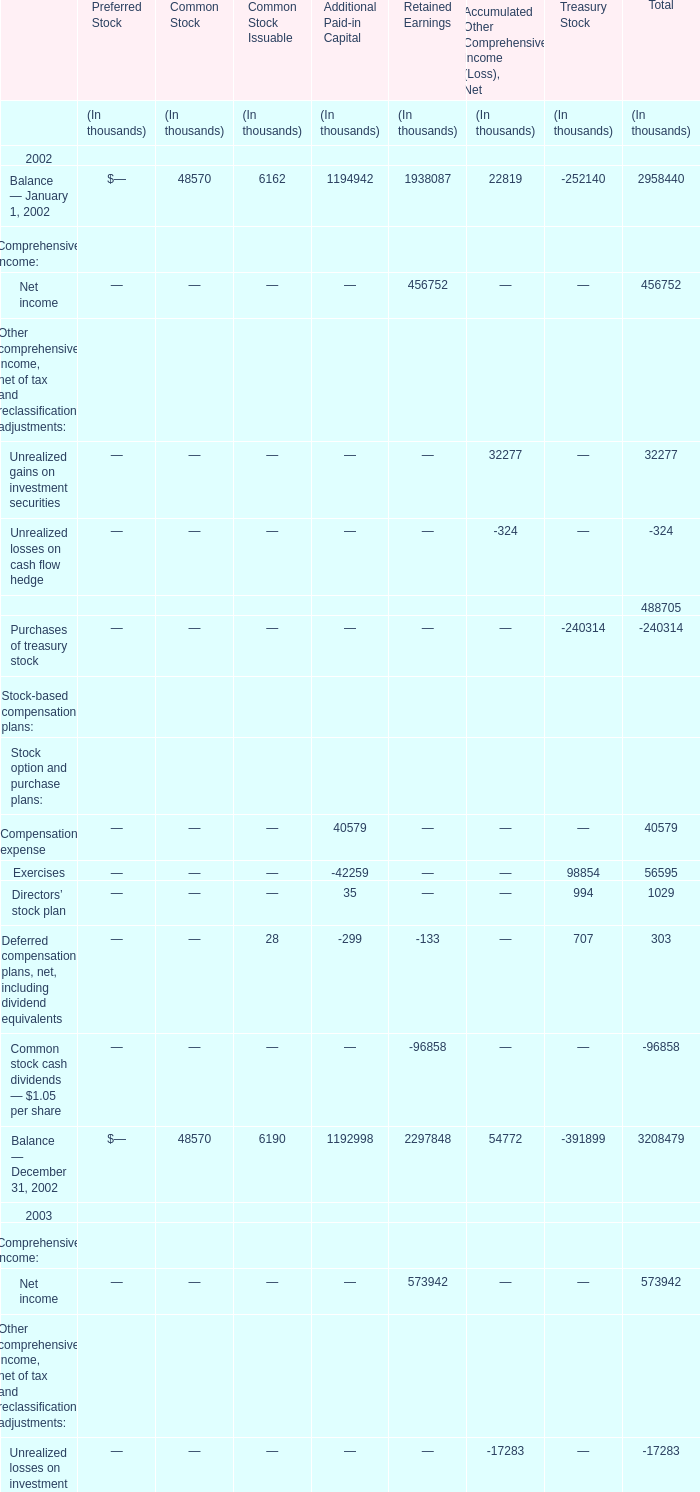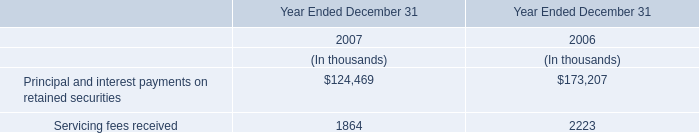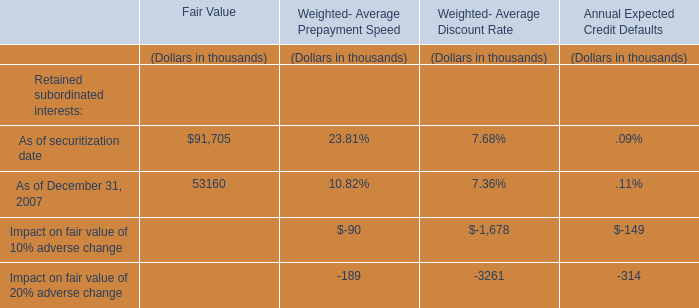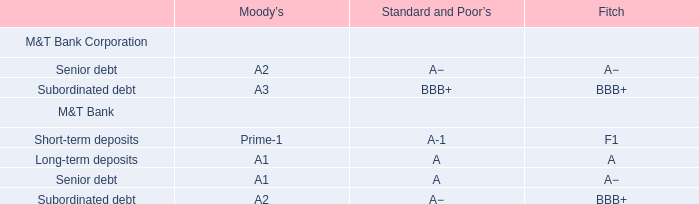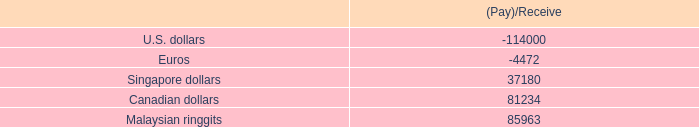How many Retained Earnings exceed the average of Retained Earnings in 2002? 
Answer: 3. 